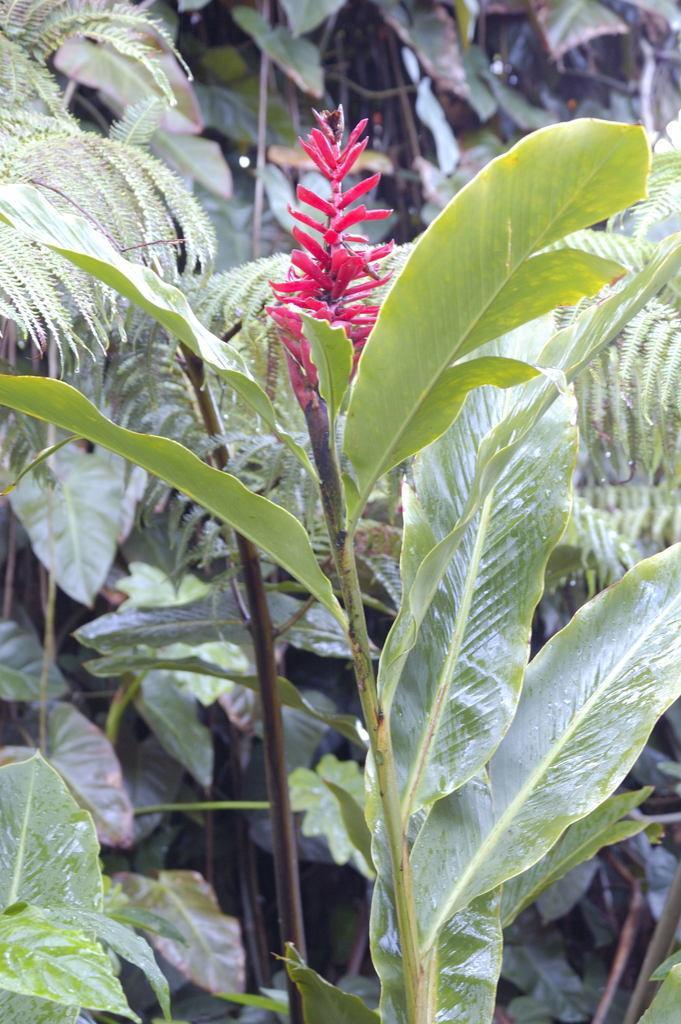Can you describe this image briefly? In this image I can see a red colour flower and number of green colour leaves. 